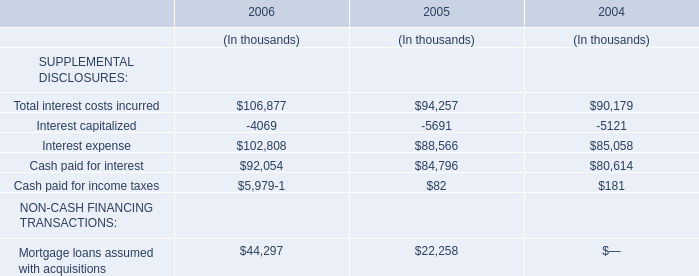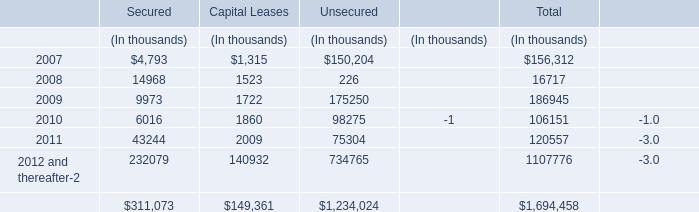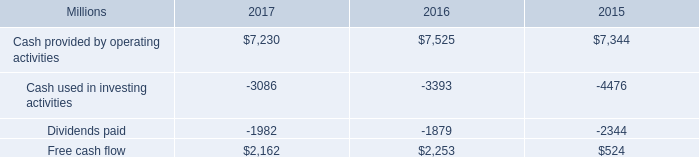what was the percentage change in free cash flow from 2015 to 2016? 
Computations: ((2253 - 524) / 524)
Answer: 3.29962. 